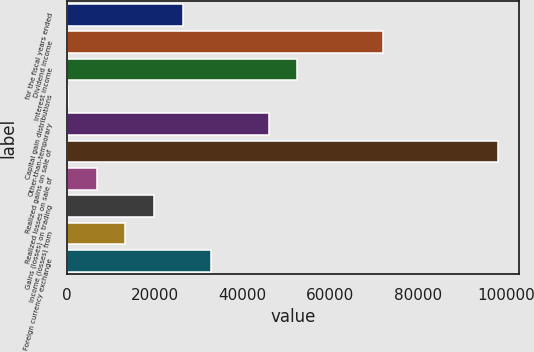<chart> <loc_0><loc_0><loc_500><loc_500><bar_chart><fcel>for the fiscal years ended<fcel>Dividend income<fcel>Interest income<fcel>Capital gain distributions<fcel>Other-than-temporary<fcel>Realized gains on sale of<fcel>Realized losses on sale of<fcel>Gains (losses) on trading<fcel>Income (losses) from<fcel>Foreign currency exchange<nl><fcel>26366.8<fcel>72060.7<fcel>52477.6<fcel>256<fcel>45949.9<fcel>98171.5<fcel>6783.7<fcel>19839.1<fcel>13311.4<fcel>32894.5<nl></chart> 